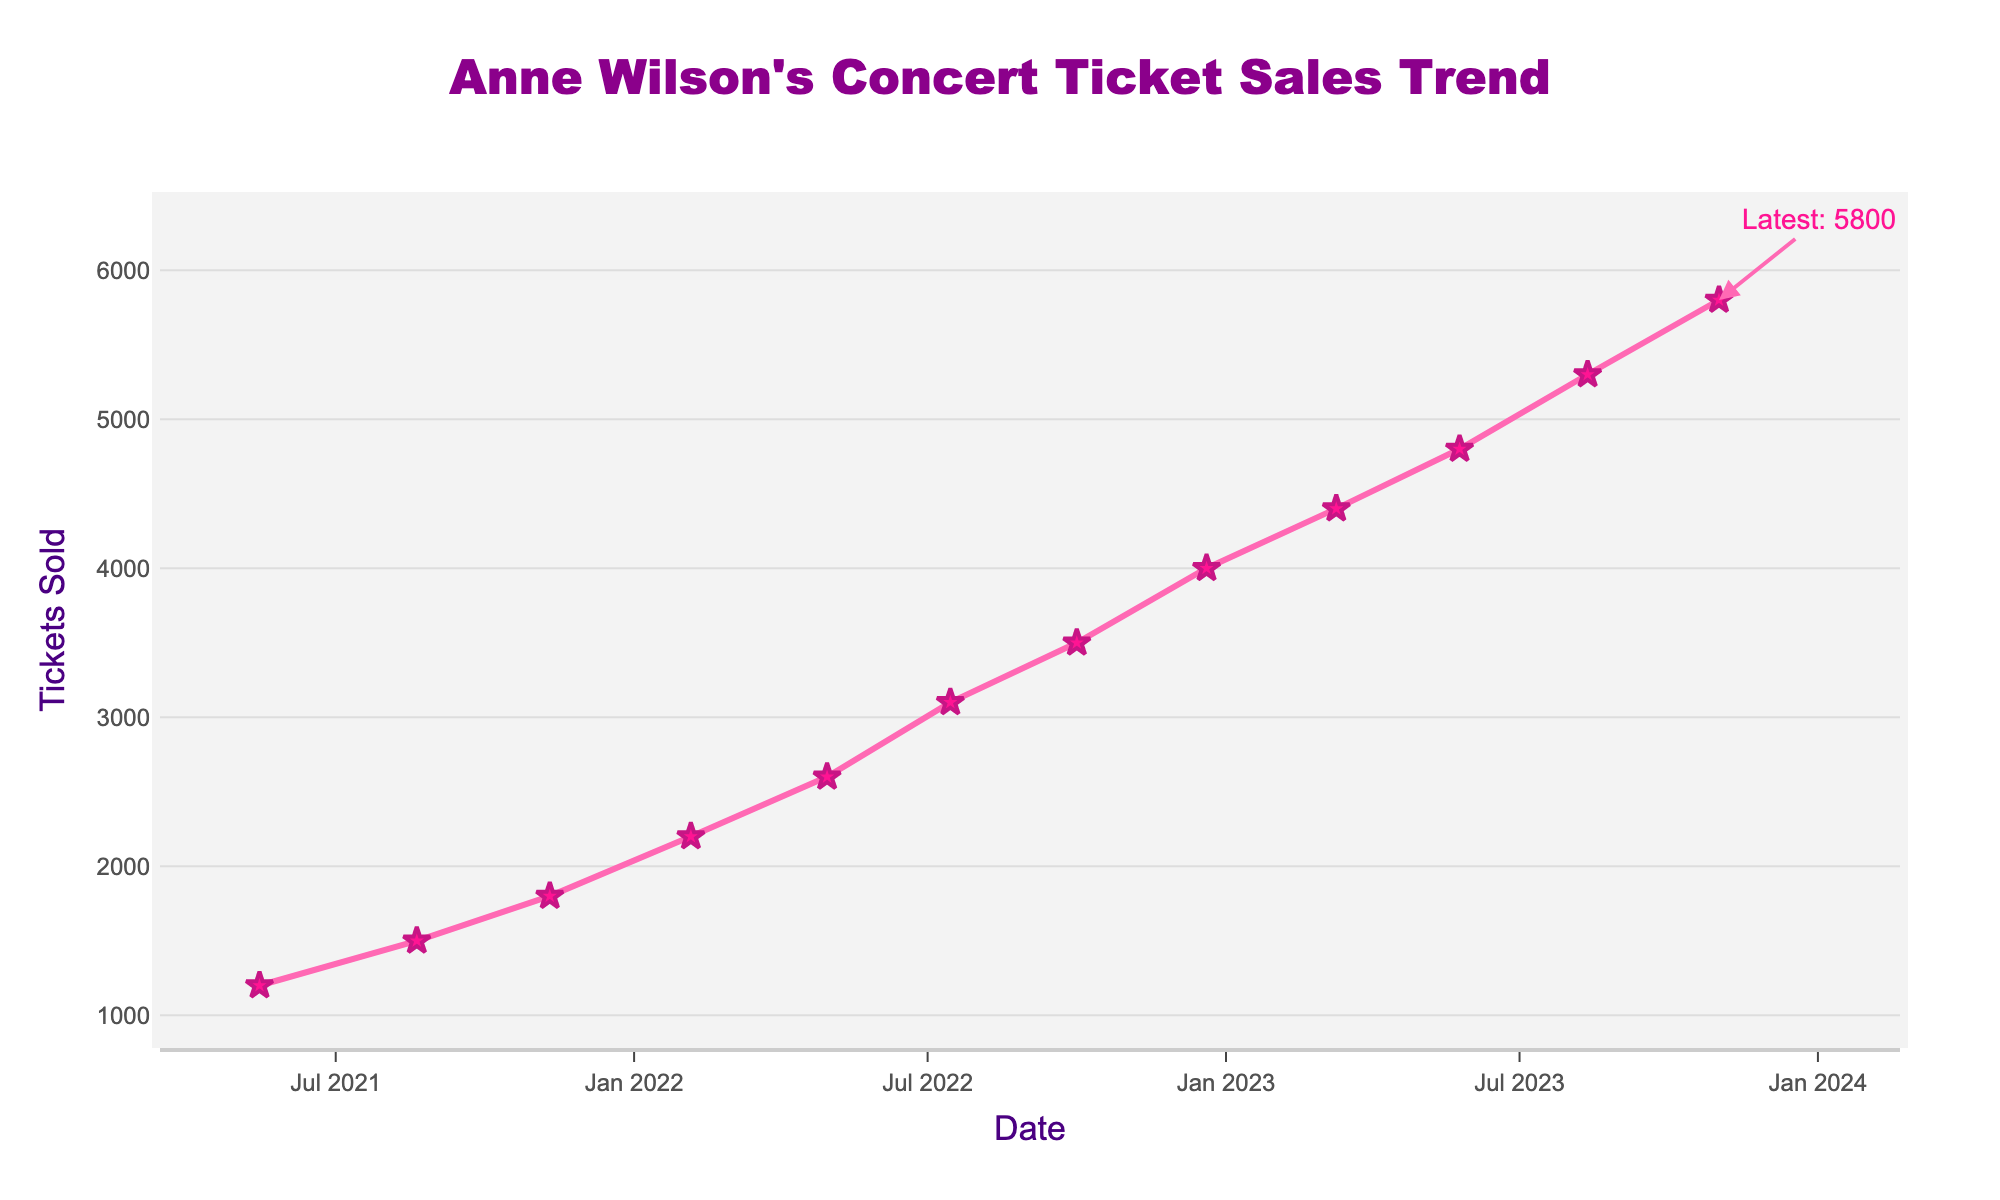What is the overall trend seen in Anne Wilson's concert ticket sales over time? The overall trend in the figure demonstrates a steady increase in ticket sales for Anne Wilson's concerts over time. This is indicated by the upward slope of the line connecting the markers on the plot.
Answer: Steady increase How many tickets were sold on August 20, 2021? Refer to the data point on August 20, 2021, on the x-axis and find its corresponding y-axis value. The plot shows 1500 tickets sold on this date.
Answer: 1500 Which concert date had the highest ticket sales? Look at the y-axis values and identify the highest point on the line chart. The highest ticket sales occurred on November 1, 2023.
Answer: November 1, 2023 By how many tickets did the sales increase from February 5, 2022, to December 20, 2022? Identify the y-axis values for February 5, 2022 (2200 tickets) and December 20, 2022 (4000 tickets). Subtract the earlier value from the later value: 4000 - 2200 = 1800.
Answer: 1800 What is the approximate average number of tickets sold over the entire period? Sum all the ticket sales: 1200 + 1500 + 1800 + 2200 + 2600 + 3100 + 3500 + 4000 + 4400 + 4800 + 5300 + 5800 = 42200. Divide by the number of data points (12): 42200 ÷ 12 ≈ 3517.
Answer: 3517 What visual elements are used to mark the data points on the chart? Observe the shapes and colors of the markers at each data point. The chart uses star-shaped markers with a dark pink color to mark the data points.
Answer: Star-shaped markers, dark pink color Between which two dates did Anne Wilson's concert tickets see the most significant increase? Compare the differences between consecutive data points. The largest increase is from December 20, 2022 (4000) to March 10, 2023 (4400), which is an increase of 400 tickets.
Answer: December 20, 2022, to March 10, 2023 How many tickets were sold for concerts in 2023 until the latest date provided? Sum the ticket sales for all 2023 dates: 4400 (March 10) + 4800 (May 25) + 5300 (August 12) + 5800 (November 1) = 20300.
Answer: 20300 What annotation is added to the plot, and what information does it provide? Identify the text and elements added to the plot besides the line and markers. The annotation shows "Latest: 5800" at the last data point, indicating the most recent ticket sales figure.
Answer: "Latest: 5800" indicating most recent sales figure 